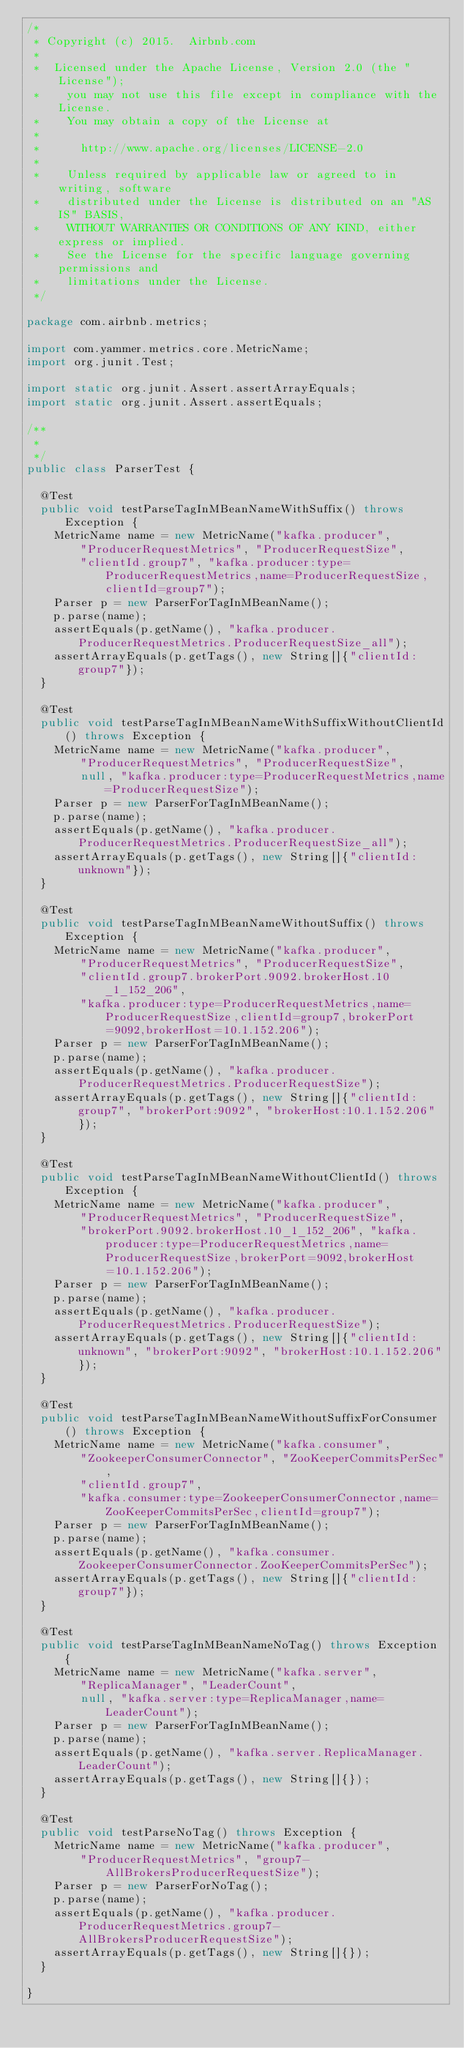<code> <loc_0><loc_0><loc_500><loc_500><_Java_>/*
 * Copyright (c) 2015.  Airbnb.com
 *
 *  Licensed under the Apache License, Version 2.0 (the "License");
 *    you may not use this file except in compliance with the License.
 *    You may obtain a copy of the License at
 *
 *      http://www.apache.org/licenses/LICENSE-2.0
 *
 *    Unless required by applicable law or agreed to in writing, software
 *    distributed under the License is distributed on an "AS IS" BASIS,
 *    WITHOUT WARRANTIES OR CONDITIONS OF ANY KIND, either express or implied.
 *    See the License for the specific language governing permissions and
 *    limitations under the License.
 */

package com.airbnb.metrics;

import com.yammer.metrics.core.MetricName;
import org.junit.Test;

import static org.junit.Assert.assertArrayEquals;
import static org.junit.Assert.assertEquals;

/**
 *
 */
public class ParserTest {

  @Test
  public void testParseTagInMBeanNameWithSuffix() throws Exception {
    MetricName name = new MetricName("kafka.producer",
        "ProducerRequestMetrics", "ProducerRequestSize",
        "clientId.group7", "kafka.producer:type=ProducerRequestMetrics,name=ProducerRequestSize,clientId=group7");
    Parser p = new ParserForTagInMBeanName();
    p.parse(name);
    assertEquals(p.getName(), "kafka.producer.ProducerRequestMetrics.ProducerRequestSize_all");
    assertArrayEquals(p.getTags(), new String[]{"clientId:group7"});
  }

  @Test
  public void testParseTagInMBeanNameWithSuffixWithoutClientId() throws Exception {
    MetricName name = new MetricName("kafka.producer",
        "ProducerRequestMetrics", "ProducerRequestSize",
        null, "kafka.producer:type=ProducerRequestMetrics,name=ProducerRequestSize");
    Parser p = new ParserForTagInMBeanName();
    p.parse(name);
    assertEquals(p.getName(), "kafka.producer.ProducerRequestMetrics.ProducerRequestSize_all");
    assertArrayEquals(p.getTags(), new String[]{"clientId:unknown"});
  }

  @Test
  public void testParseTagInMBeanNameWithoutSuffix() throws Exception {
    MetricName name = new MetricName("kafka.producer",
        "ProducerRequestMetrics", "ProducerRequestSize",
        "clientId.group7.brokerPort.9092.brokerHost.10_1_152_206",
        "kafka.producer:type=ProducerRequestMetrics,name=ProducerRequestSize,clientId=group7,brokerPort=9092,brokerHost=10.1.152.206");
    Parser p = new ParserForTagInMBeanName();
    p.parse(name);
    assertEquals(p.getName(), "kafka.producer.ProducerRequestMetrics.ProducerRequestSize");
    assertArrayEquals(p.getTags(), new String[]{"clientId:group7", "brokerPort:9092", "brokerHost:10.1.152.206"});
  }

  @Test
  public void testParseTagInMBeanNameWithoutClientId() throws Exception {
    MetricName name = new MetricName("kafka.producer",
        "ProducerRequestMetrics", "ProducerRequestSize",
        "brokerPort.9092.brokerHost.10_1_152_206", "kafka.producer:type=ProducerRequestMetrics,name=ProducerRequestSize,brokerPort=9092,brokerHost=10.1.152.206");
    Parser p = new ParserForTagInMBeanName();
    p.parse(name);
    assertEquals(p.getName(), "kafka.producer.ProducerRequestMetrics.ProducerRequestSize");
    assertArrayEquals(p.getTags(), new String[]{"clientId:unknown", "brokerPort:9092", "brokerHost:10.1.152.206"});
  }

  @Test
  public void testParseTagInMBeanNameWithoutSuffixForConsumer() throws Exception {
    MetricName name = new MetricName("kafka.consumer",
        "ZookeeperConsumerConnector", "ZooKeeperCommitsPerSec",
        "clientId.group7",
        "kafka.consumer:type=ZookeeperConsumerConnector,name=ZooKeeperCommitsPerSec,clientId=group7");
    Parser p = new ParserForTagInMBeanName();
    p.parse(name);
    assertEquals(p.getName(), "kafka.consumer.ZookeeperConsumerConnector.ZooKeeperCommitsPerSec");
    assertArrayEquals(p.getTags(), new String[]{"clientId:group7"});
  }

  @Test
  public void testParseTagInMBeanNameNoTag() throws Exception {
    MetricName name = new MetricName("kafka.server",
        "ReplicaManager", "LeaderCount",
        null, "kafka.server:type=ReplicaManager,name=LeaderCount");
    Parser p = new ParserForTagInMBeanName();
    p.parse(name);
    assertEquals(p.getName(), "kafka.server.ReplicaManager.LeaderCount");
    assertArrayEquals(p.getTags(), new String[]{});
  }

  @Test
  public void testParseNoTag() throws Exception {
    MetricName name = new MetricName("kafka.producer",
        "ProducerRequestMetrics", "group7-AllBrokersProducerRequestSize");
    Parser p = new ParserForNoTag();
    p.parse(name);
    assertEquals(p.getName(), "kafka.producer.ProducerRequestMetrics.group7-AllBrokersProducerRequestSize");
    assertArrayEquals(p.getTags(), new String[]{});
  }

}
</code> 